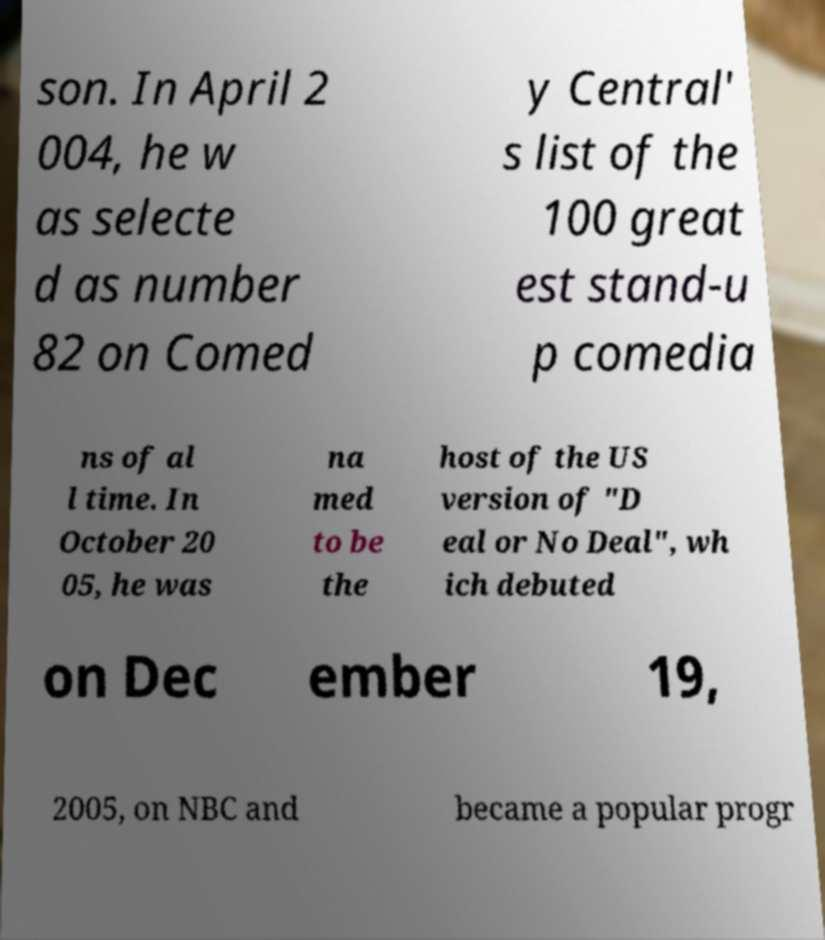Could you assist in decoding the text presented in this image and type it out clearly? son. In April 2 004, he w as selecte d as number 82 on Comed y Central' s list of the 100 great est stand-u p comedia ns of al l time. In October 20 05, he was na med to be the host of the US version of "D eal or No Deal", wh ich debuted on Dec ember 19, 2005, on NBC and became a popular progr 